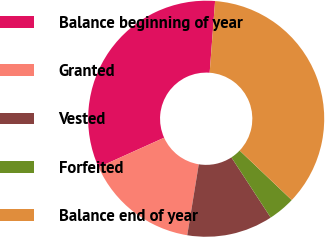Convert chart to OTSL. <chart><loc_0><loc_0><loc_500><loc_500><pie_chart><fcel>Balance beginning of year<fcel>Granted<fcel>Vested<fcel>Forfeited<fcel>Balance end of year<nl><fcel>32.95%<fcel>15.69%<fcel>11.77%<fcel>3.7%<fcel>35.9%<nl></chart> 